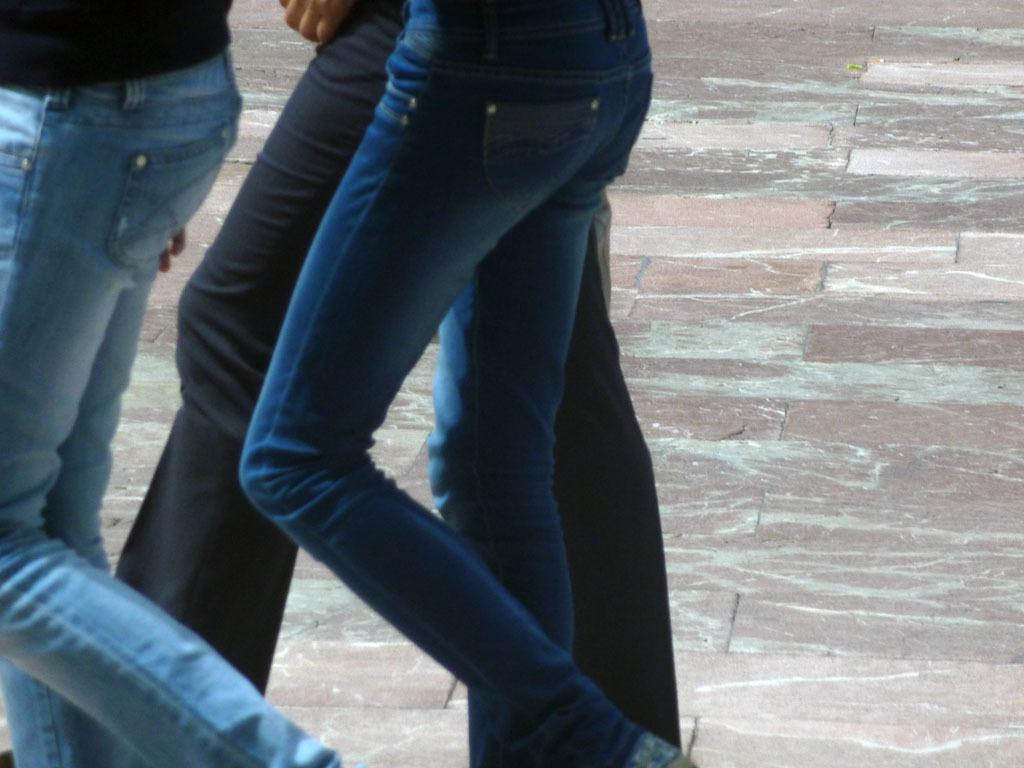How many people are in the image? There are three persons in the image. What are the persons doing in the image? The persons are walking. What color are the jeans worn by the persons in the image? The persons are wearing blue color jeans. How would you describe the floor in the image? The floor has multiple colors. What is the occasion for the birthday celebration in the image? There is no birthday celebration present in the image. What thoughts are going through the minds of the persons in the image? We cannot determine the thoughts of the persons in the image based on the provided facts. 